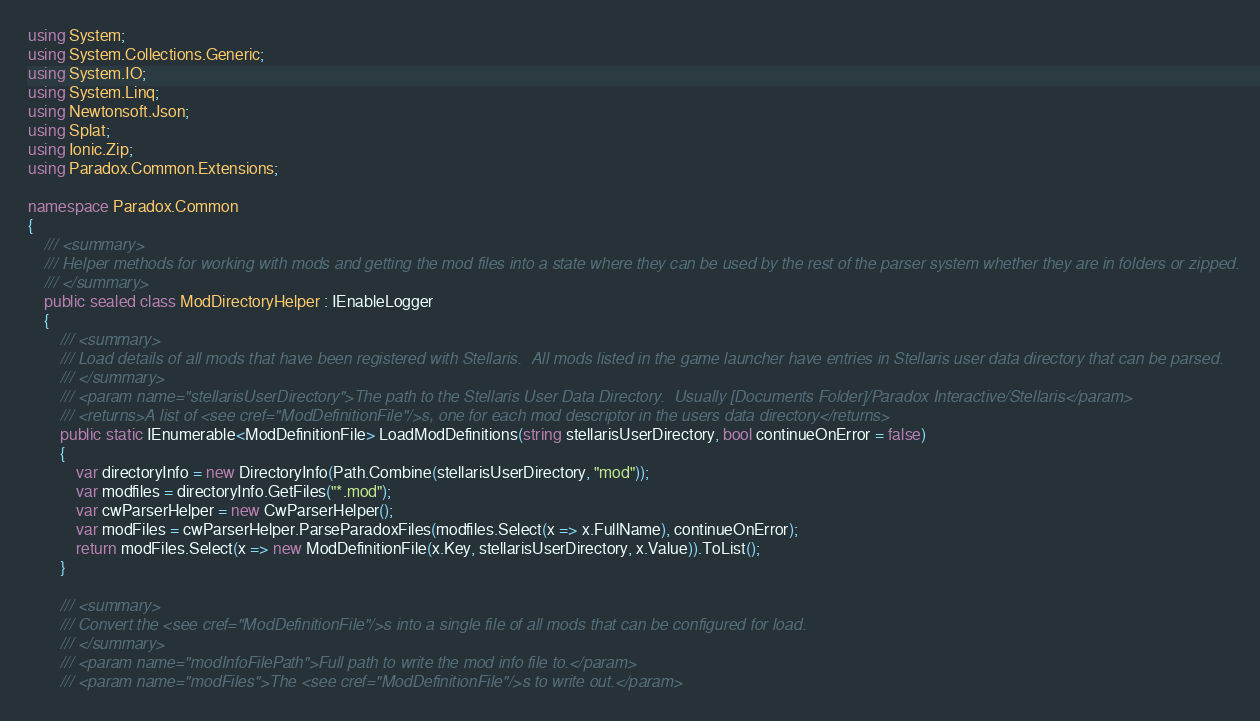Convert code to text. <code><loc_0><loc_0><loc_500><loc_500><_C#_>using System;
using System.Collections.Generic;
using System.IO;
using System.Linq;
using Newtonsoft.Json;
using Splat;
using Ionic.Zip;
using Paradox.Common.Extensions;

namespace Paradox.Common
{
    /// <summary>
    /// Helper methods for working with mods and getting the mod files into a state where they can be used by the rest of the parser system whether they are in folders or zipped. 
    /// </summary>
    public sealed class ModDirectoryHelper : IEnableLogger
    {
        /// <summary>
        /// Load details of all mods that have been registered with Stellaris.  All mods listed in the game launcher have entries in Stellaris user data directory that can be parsed.
        /// </summary>
        /// <param name="stellarisUserDirectory">The path to the Stellaris User Data Directory.  Usually [Documents Folder]/Paradox Interactive/Stellaris</param>
        /// <returns>A list of <see cref="ModDefinitionFile"/>s, one for each mod descriptor in the users data directory</returns>
        public static IEnumerable<ModDefinitionFile> LoadModDefinitions(string stellarisUserDirectory, bool continueOnError = false)
        {
            var directoryInfo = new DirectoryInfo(Path.Combine(stellarisUserDirectory, "mod"));
            var modfiles = directoryInfo.GetFiles("*.mod");
            var cwParserHelper = new CwParserHelper();
            var modFiles = cwParserHelper.ParseParadoxFiles(modfiles.Select(x => x.FullName), continueOnError);
            return modFiles.Select(x => new ModDefinitionFile(x.Key, stellarisUserDirectory, x.Value)).ToList();
        }

        /// <summary>
        /// Convert the <see cref="ModDefinitionFile"/>s into a single file of all mods that can be configured for load.
        /// </summary>
        /// <param name="modInfoFilePath">Full path to write the mod info file to.</param>
        /// <param name="modFiles">The <see cref="ModDefinitionFile"/>s to write out.</param></code> 